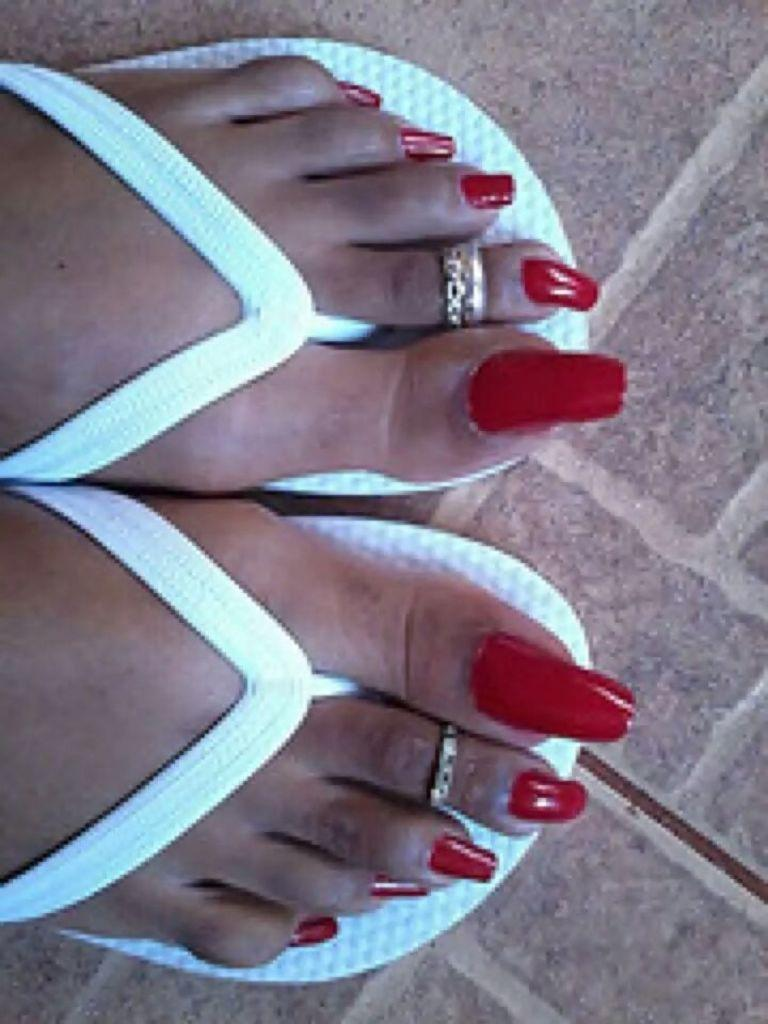What body part is visible in the image? There are a person's legs visible in the image. What type of footwear is the person wearing? The person is wearing slippers. Where are the person's legs located? The person's legs are on a path. What type of accessory is present on the person's toes? There are toe rings on the person's toes. How many jellyfish can be seen in the image? There are no jellyfish present in the image. What type of nail is being used by the person in the image? There is no nail visible in the image; only the person's legs, slippers, and toe rings are present. 